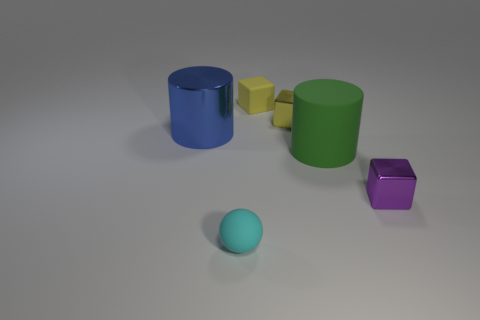Is there a cube that has the same material as the blue thing?
Give a very brief answer. Yes. How many gray things are small metal cylinders or tiny rubber cubes?
Offer a terse response. 0. What size is the shiny object that is both in front of the tiny yellow metallic thing and right of the big metallic object?
Offer a terse response. Small. Are there more cylinders in front of the small cyan rubber sphere than tiny yellow blocks?
Your answer should be compact. No. How many blocks are blue matte things or blue things?
Your response must be concise. 0. There is a small thing that is behind the blue metal cylinder and to the left of the tiny yellow shiny object; what shape is it?
Keep it short and to the point. Cube. Is the number of small matte cubes that are on the right side of the yellow metal object the same as the number of small purple blocks left of the green object?
Provide a short and direct response. Yes. What number of things are metallic balls or tiny purple metallic objects?
Give a very brief answer. 1. There is another metallic object that is the same size as the green thing; what color is it?
Your response must be concise. Blue. What number of things are either balls that are to the left of the green rubber thing or tiny yellow things in front of the small yellow rubber thing?
Make the answer very short. 2. 